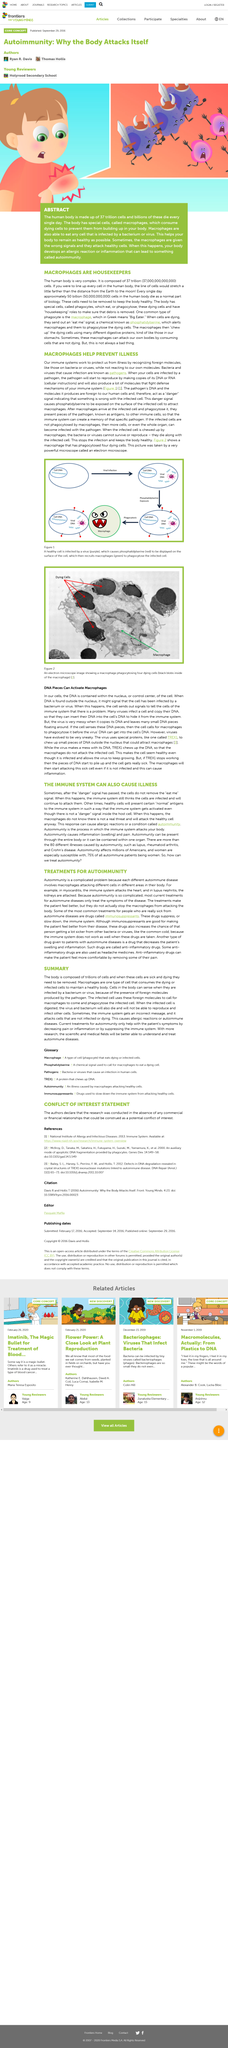Draw attention to some important aspects in this diagram. If macrophages receive the wrong signals, they can attack healthy cells, leading to adverse effects on the body. When macrophages attack healthy cells, it can lead to an allergic reaction or inflammation that has the potential to cause autoimmunity in the body. This can result in the immune system mistakenly attacking healthy cells and tissues, leading to a range of serious health problems. It is essential to maintain a healthy balance of immune cells and to manage inflammation in order to prevent the development of autoimmunity and related diseases. The human body is composed of 37 trillion cells, making it a complex and intricate system of tiny, specialized units that work together to keep us alive. 